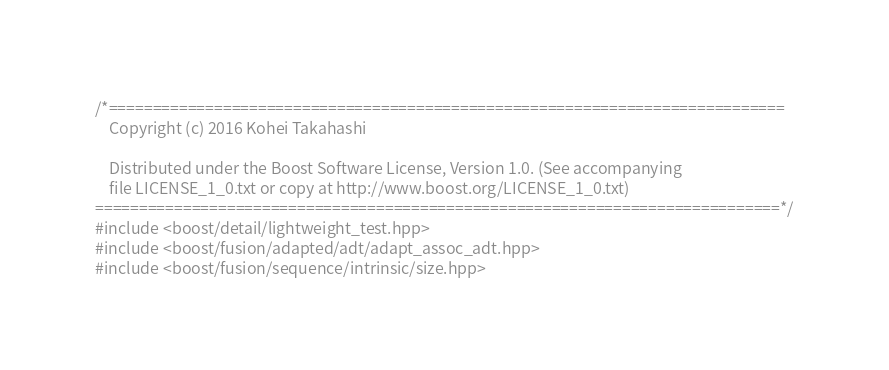Convert code to text. <code><loc_0><loc_0><loc_500><loc_500><_C++_>/*=============================================================================
    Copyright (c) 2016 Kohei Takahashi

    Distributed under the Boost Software License, Version 1.0. (See accompanying
    file LICENSE_1_0.txt or copy at http://www.boost.org/LICENSE_1_0.txt)
==============================================================================*/
#include <boost/detail/lightweight_test.hpp>
#include <boost/fusion/adapted/adt/adapt_assoc_adt.hpp>
#include <boost/fusion/sequence/intrinsic/size.hpp></code> 